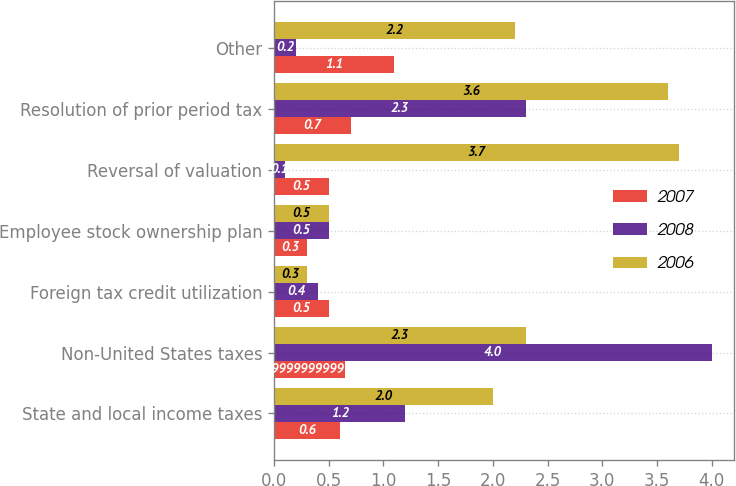Convert chart to OTSL. <chart><loc_0><loc_0><loc_500><loc_500><stacked_bar_chart><ecel><fcel>State and local income taxes<fcel>Non-United States taxes<fcel>Foreign tax credit utilization<fcel>Employee stock ownership plan<fcel>Reversal of valuation<fcel>Resolution of prior period tax<fcel>Other<nl><fcel>2007<fcel>0.6<fcel>0.65<fcel>0.5<fcel>0.3<fcel>0.5<fcel>0.7<fcel>1.1<nl><fcel>2008<fcel>1.2<fcel>4<fcel>0.4<fcel>0.5<fcel>0.1<fcel>2.3<fcel>0.2<nl><fcel>2006<fcel>2<fcel>2.3<fcel>0.3<fcel>0.5<fcel>3.7<fcel>3.6<fcel>2.2<nl></chart> 